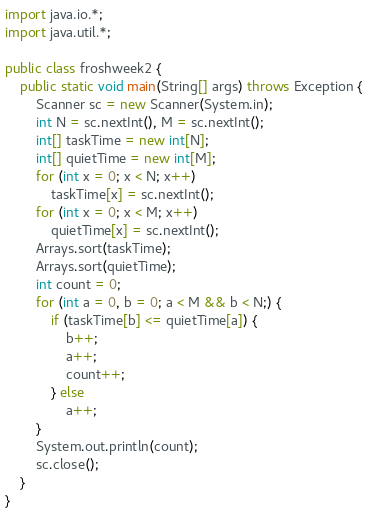Convert code to text. <code><loc_0><loc_0><loc_500><loc_500><_Java_>import java.io.*;
import java.util.*;

public class froshweek2 {
    public static void main(String[] args) throws Exception {
        Scanner sc = new Scanner(System.in);
        int N = sc.nextInt(), M = sc.nextInt();
        int[] taskTime = new int[N];
        int[] quietTime = new int[M];
        for (int x = 0; x < N; x++)
            taskTime[x] = sc.nextInt();
        for (int x = 0; x < M; x++)
            quietTime[x] = sc.nextInt();
        Arrays.sort(taskTime);
        Arrays.sort(quietTime);
        int count = 0;
        for (int a = 0, b = 0; a < M && b < N;) {
            if (taskTime[b] <= quietTime[a]) {
                b++;
                a++;
                count++;
            } else
                a++;
        }
        System.out.println(count);
        sc.close();
    }
}</code> 